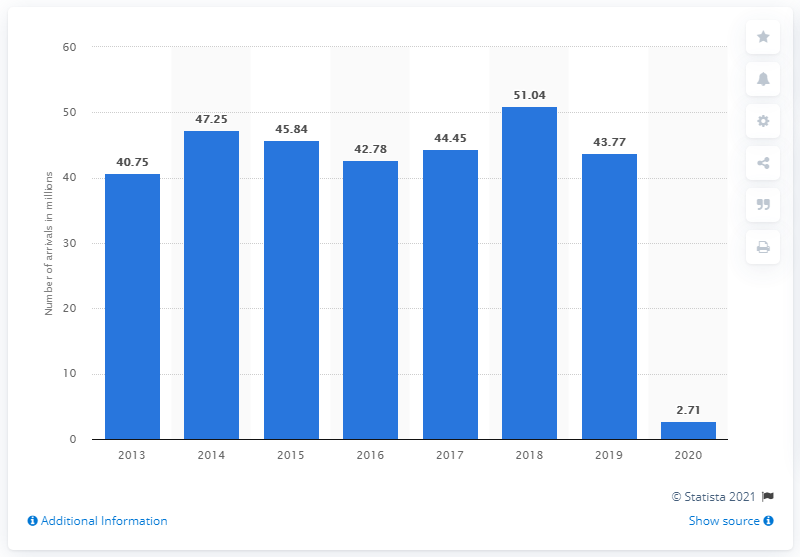Mention a couple of crucial points in this snapshot. In the previous year, a total of 43,770 visitors arrived in Hong Kong from mainland China. In 2020, a total of 2,710,000 visitors arrived in Hong Kong from mainland China. 